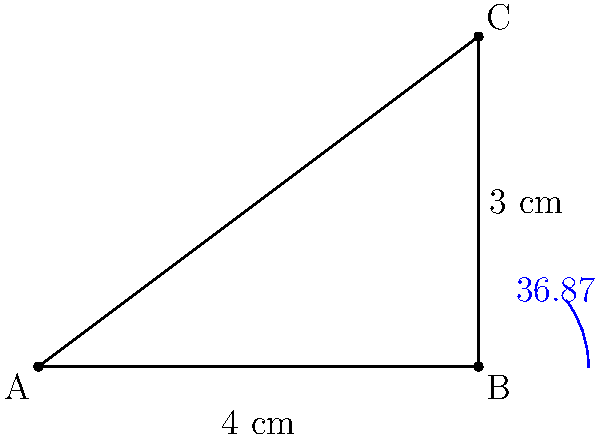During a specialized X-ray procedure, a patient needs to be rotated from a supine position to optimize image quality. Given the diagram representing the patient's position, where AB is 4 cm and BC is 3 cm, calculate the angle of rotation needed to achieve the correct positioning. Round your answer to the nearest hundredth of a degree. To find the angle of rotation, we need to calculate the angle ABC in the right-angled triangle. We can use the inverse tangent (arctan) function to do this.

Step 1: Identify the sides of the right-angled triangle.
- Adjacent side (AB) = 4 cm
- Opposite side (BC) = 3 cm

Step 2: Use the tangent function to set up the equation.
$\tan(\theta) = \frac{\text{opposite}}{\text{adjacent}} = \frac{BC}{AB} = \frac{3}{4}$

Step 3: Take the inverse tangent (arctan) of both sides.
$\theta = \arctan(\frac{3}{4})$

Step 4: Calculate the result using a calculator or computer.
$\theta \approx 36.8699°$

Step 5: Round to the nearest hundredth of a degree.
$\theta \approx 36.87°$

Therefore, the patient needs to be rotated by approximately 36.87° from the supine position to achieve the correct positioning for the X-ray procedure.
Answer: $36.87°$ 